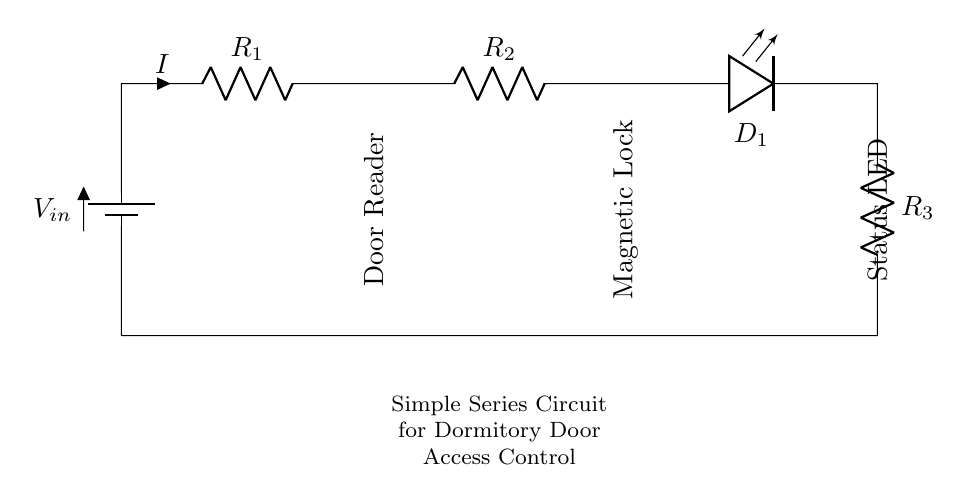What is the input voltage of this circuit? The input voltage is labeled as V-in, which is the voltage provided to the circuit. Since it's not specified, we generally assume it to be a standard value used in such circuits.
Answer: V-in What are the resistances present in the circuit? The circuit has three resistors labeled R-1, R-2, and R-3. Each resistor's value is not specified, but they are all essential for current control in the circuit.
Answer: R-1, R-2, R-3 Which component indicates the door is locked? The magnetic lock is the component that indicates the door is locked. It is labeled as "Magnetic Lock" in the circuit diagram.
Answer: Magnetic Lock What is the purpose of component D-1 in the circuit? Component D-1 is a status LED which indicates when the circuit is active or when the door is operational. LEDs are commonly used for visual feedback in circuits.
Answer: Status LED What happens to the current when R-2 is increased? Increasing R-2 would result in decreased overall current in the circuit due to the increased resistance in the series connection, according to Ohm’s law, since the total resistance would rise.
Answer: Current decreases How do the components connect in this series circuit? In a series circuit, all components are arranged in a single path. The current flows from the battery through R-1, R-2, then through LED D-1, and finally through R-3 back to the battery.
Answer: Single path 